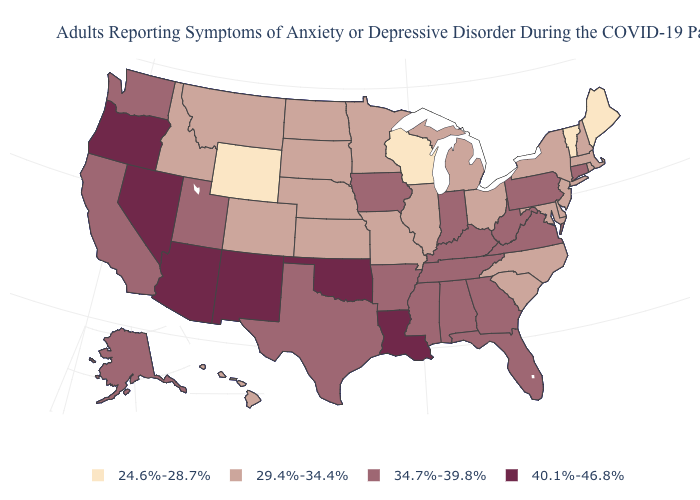How many symbols are there in the legend?
Keep it brief. 4. What is the value of Florida?
Keep it brief. 34.7%-39.8%. Name the states that have a value in the range 24.6%-28.7%?
Quick response, please. Maine, Vermont, Wisconsin, Wyoming. Does Tennessee have the highest value in the USA?
Be succinct. No. What is the lowest value in the USA?
Concise answer only. 24.6%-28.7%. What is the value of Arkansas?
Concise answer only. 34.7%-39.8%. Does the first symbol in the legend represent the smallest category?
Give a very brief answer. Yes. How many symbols are there in the legend?
Give a very brief answer. 4. Name the states that have a value in the range 40.1%-46.8%?
Short answer required. Arizona, Louisiana, Nevada, New Mexico, Oklahoma, Oregon. What is the highest value in the Northeast ?
Short answer required. 34.7%-39.8%. Which states have the lowest value in the South?
Be succinct. Delaware, Maryland, North Carolina, South Carolina. Name the states that have a value in the range 29.4%-34.4%?
Write a very short answer. Colorado, Delaware, Hawaii, Idaho, Illinois, Kansas, Maryland, Massachusetts, Michigan, Minnesota, Missouri, Montana, Nebraska, New Hampshire, New Jersey, New York, North Carolina, North Dakota, Ohio, Rhode Island, South Carolina, South Dakota. Name the states that have a value in the range 29.4%-34.4%?
Keep it brief. Colorado, Delaware, Hawaii, Idaho, Illinois, Kansas, Maryland, Massachusetts, Michigan, Minnesota, Missouri, Montana, Nebraska, New Hampshire, New Jersey, New York, North Carolina, North Dakota, Ohio, Rhode Island, South Carolina, South Dakota. What is the value of Colorado?
Short answer required. 29.4%-34.4%. Name the states that have a value in the range 24.6%-28.7%?
Keep it brief. Maine, Vermont, Wisconsin, Wyoming. 